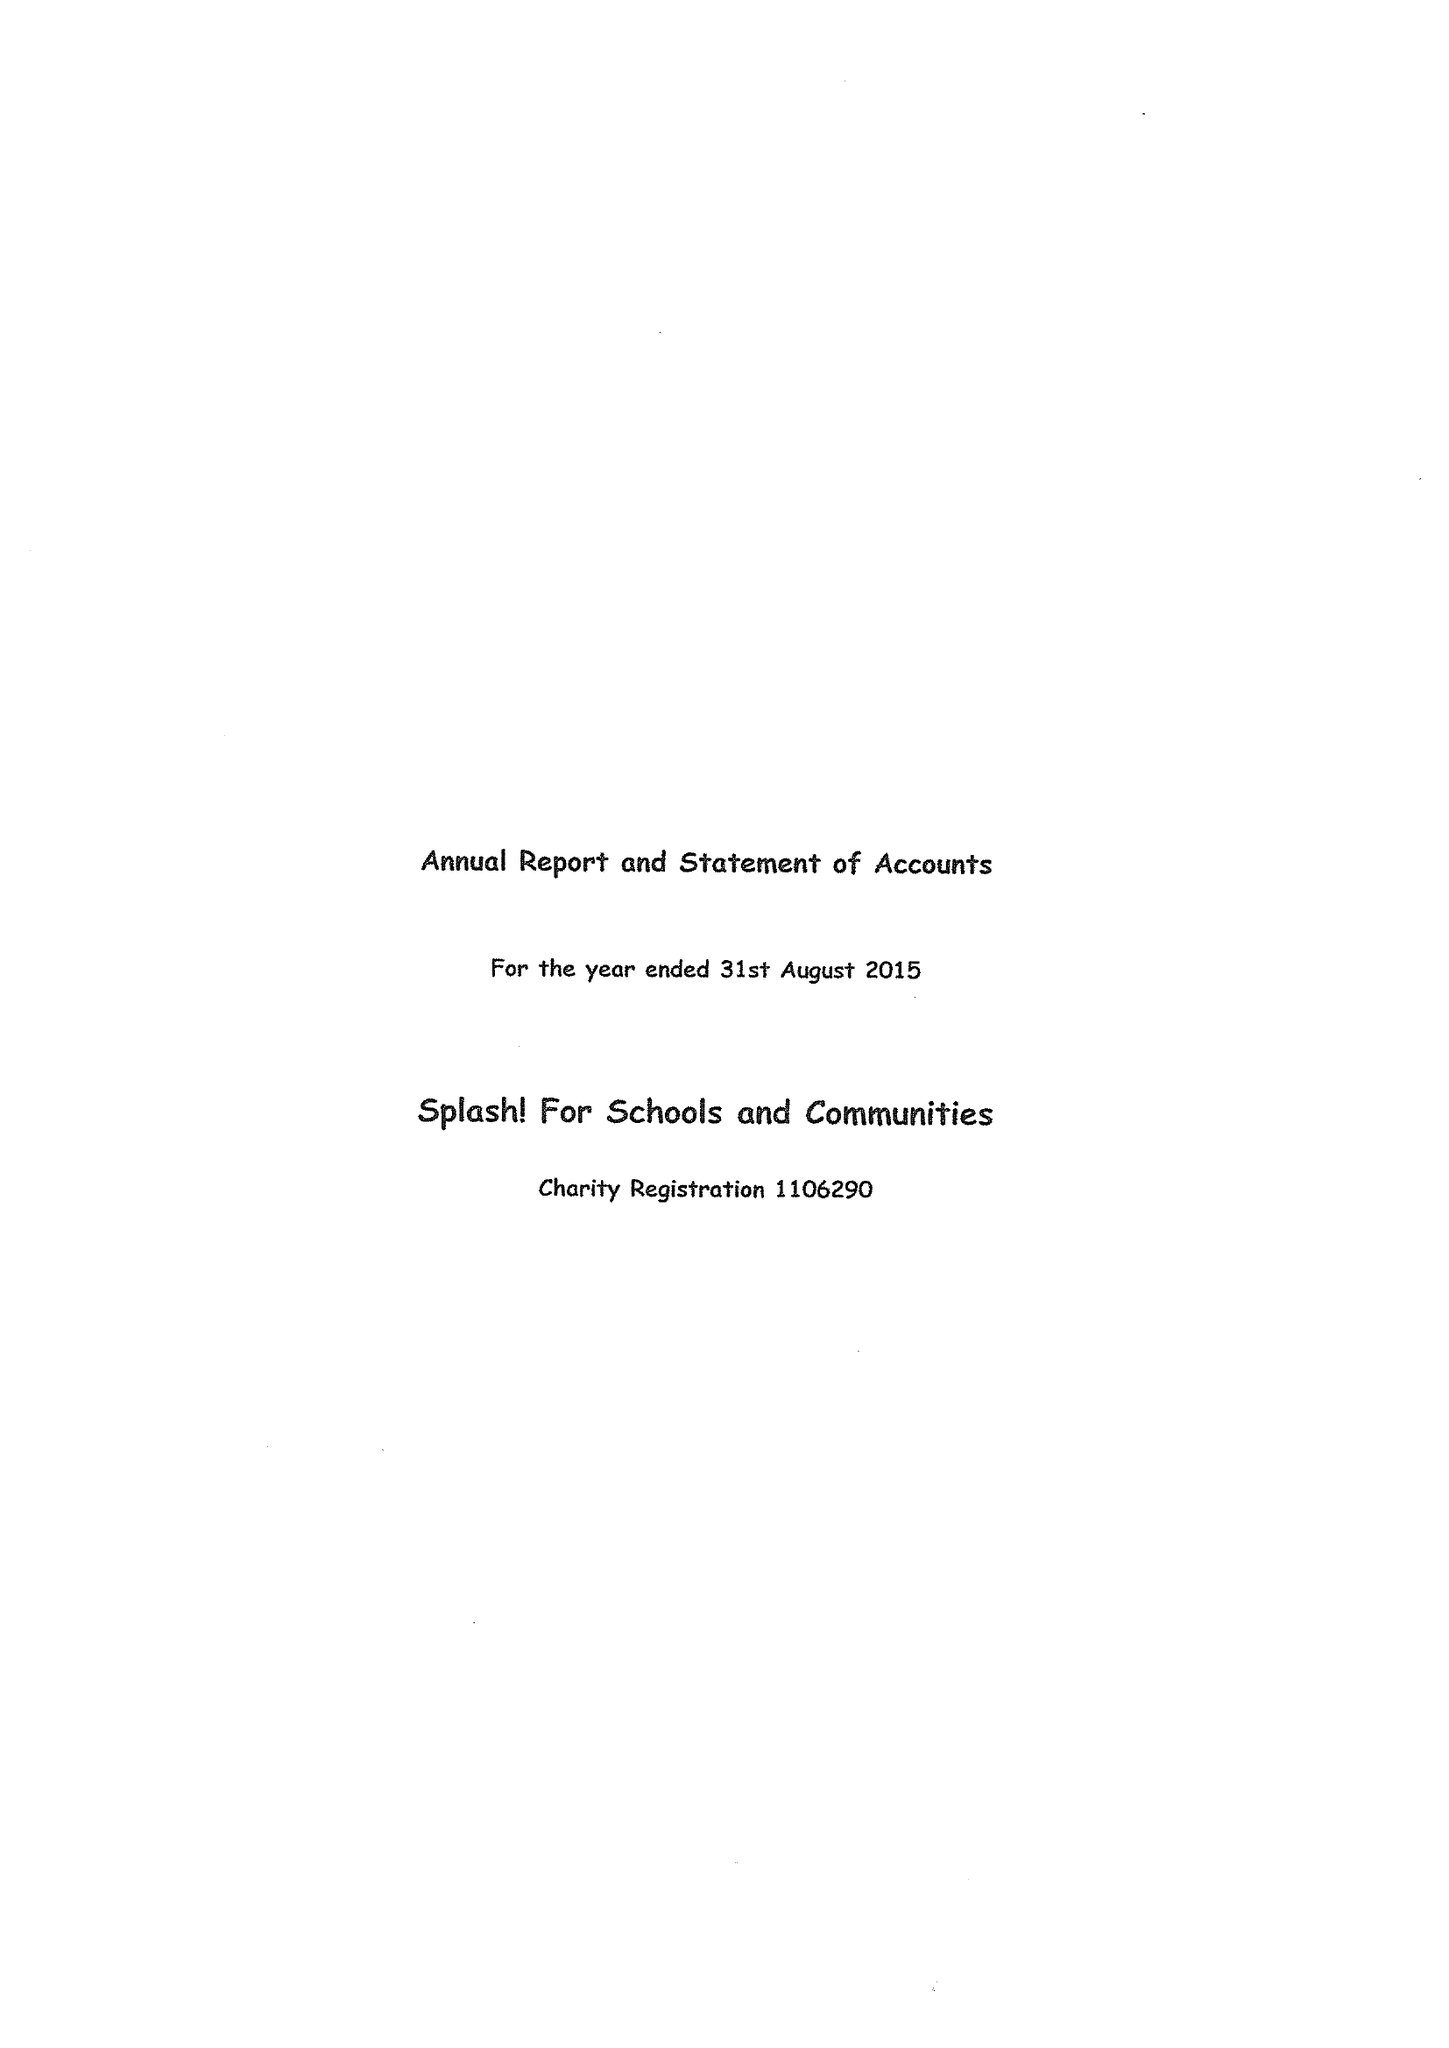What is the value for the income_annually_in_british_pounds?
Answer the question using a single word or phrase. 63859.00 